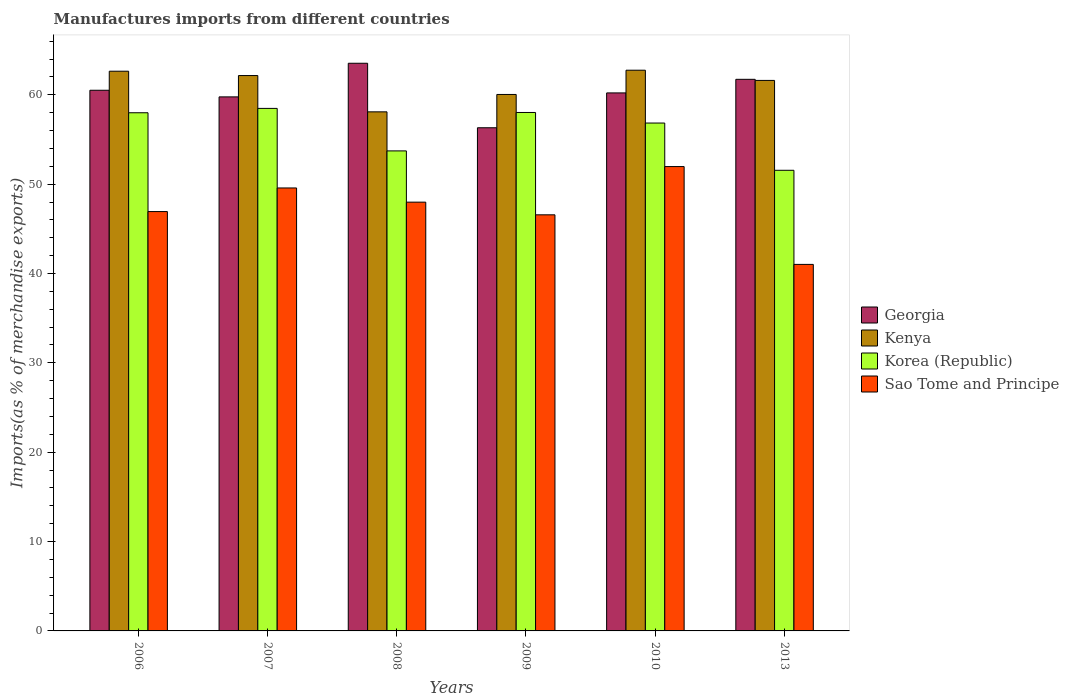How many different coloured bars are there?
Offer a very short reply. 4. Are the number of bars per tick equal to the number of legend labels?
Give a very brief answer. Yes. Are the number of bars on each tick of the X-axis equal?
Keep it short and to the point. Yes. How many bars are there on the 5th tick from the right?
Offer a terse response. 4. In how many cases, is the number of bars for a given year not equal to the number of legend labels?
Keep it short and to the point. 0. What is the percentage of imports to different countries in Sao Tome and Principe in 2008?
Offer a terse response. 47.98. Across all years, what is the maximum percentage of imports to different countries in Sao Tome and Principe?
Keep it short and to the point. 51.97. Across all years, what is the minimum percentage of imports to different countries in Korea (Republic)?
Offer a terse response. 51.55. In which year was the percentage of imports to different countries in Korea (Republic) maximum?
Ensure brevity in your answer.  2007. In which year was the percentage of imports to different countries in Kenya minimum?
Offer a terse response. 2008. What is the total percentage of imports to different countries in Korea (Republic) in the graph?
Your response must be concise. 336.59. What is the difference between the percentage of imports to different countries in Kenya in 2009 and that in 2010?
Your answer should be very brief. -2.72. What is the difference between the percentage of imports to different countries in Sao Tome and Principe in 2007 and the percentage of imports to different countries in Georgia in 2010?
Keep it short and to the point. -10.64. What is the average percentage of imports to different countries in Georgia per year?
Your answer should be compact. 60.34. In the year 2009, what is the difference between the percentage of imports to different countries in Georgia and percentage of imports to different countries in Sao Tome and Principe?
Give a very brief answer. 9.74. In how many years, is the percentage of imports to different countries in Sao Tome and Principe greater than 58 %?
Your response must be concise. 0. What is the ratio of the percentage of imports to different countries in Georgia in 2007 to that in 2008?
Keep it short and to the point. 0.94. What is the difference between the highest and the second highest percentage of imports to different countries in Kenya?
Your answer should be very brief. 0.11. What is the difference between the highest and the lowest percentage of imports to different countries in Sao Tome and Principe?
Ensure brevity in your answer.  10.95. Is the sum of the percentage of imports to different countries in Kenya in 2009 and 2010 greater than the maximum percentage of imports to different countries in Georgia across all years?
Your answer should be very brief. Yes. What does the 2nd bar from the left in 2009 represents?
Offer a very short reply. Kenya. What does the 3rd bar from the right in 2008 represents?
Keep it short and to the point. Kenya. Is it the case that in every year, the sum of the percentage of imports to different countries in Georgia and percentage of imports to different countries in Kenya is greater than the percentage of imports to different countries in Sao Tome and Principe?
Offer a very short reply. Yes. How many years are there in the graph?
Your response must be concise. 6. What is the difference between two consecutive major ticks on the Y-axis?
Offer a very short reply. 10. Are the values on the major ticks of Y-axis written in scientific E-notation?
Your response must be concise. No. Does the graph contain any zero values?
Provide a short and direct response. No. Does the graph contain grids?
Offer a very short reply. No. How many legend labels are there?
Your answer should be very brief. 4. What is the title of the graph?
Offer a terse response. Manufactures imports from different countries. Does "Chile" appear as one of the legend labels in the graph?
Your answer should be compact. No. What is the label or title of the Y-axis?
Your answer should be very brief. Imports(as % of merchandise exports). What is the Imports(as % of merchandise exports) in Georgia in 2006?
Your answer should be very brief. 60.51. What is the Imports(as % of merchandise exports) in Kenya in 2006?
Ensure brevity in your answer.  62.64. What is the Imports(as % of merchandise exports) of Korea (Republic) in 2006?
Your answer should be very brief. 57.99. What is the Imports(as % of merchandise exports) of Sao Tome and Principe in 2006?
Give a very brief answer. 46.93. What is the Imports(as % of merchandise exports) of Georgia in 2007?
Make the answer very short. 59.76. What is the Imports(as % of merchandise exports) in Kenya in 2007?
Your response must be concise. 62.15. What is the Imports(as % of merchandise exports) in Korea (Republic) in 2007?
Offer a very short reply. 58.48. What is the Imports(as % of merchandise exports) in Sao Tome and Principe in 2007?
Provide a succinct answer. 49.57. What is the Imports(as % of merchandise exports) of Georgia in 2008?
Provide a succinct answer. 63.53. What is the Imports(as % of merchandise exports) of Kenya in 2008?
Your answer should be compact. 58.09. What is the Imports(as % of merchandise exports) of Korea (Republic) in 2008?
Provide a succinct answer. 53.72. What is the Imports(as % of merchandise exports) in Sao Tome and Principe in 2008?
Provide a succinct answer. 47.98. What is the Imports(as % of merchandise exports) of Georgia in 2009?
Your answer should be compact. 56.31. What is the Imports(as % of merchandise exports) in Kenya in 2009?
Your answer should be compact. 60.03. What is the Imports(as % of merchandise exports) in Korea (Republic) in 2009?
Ensure brevity in your answer.  58.02. What is the Imports(as % of merchandise exports) of Sao Tome and Principe in 2009?
Your answer should be very brief. 46.57. What is the Imports(as % of merchandise exports) of Georgia in 2010?
Your answer should be compact. 60.21. What is the Imports(as % of merchandise exports) in Kenya in 2010?
Make the answer very short. 62.75. What is the Imports(as % of merchandise exports) in Korea (Republic) in 2010?
Your answer should be very brief. 56.84. What is the Imports(as % of merchandise exports) in Sao Tome and Principe in 2010?
Provide a succinct answer. 51.97. What is the Imports(as % of merchandise exports) in Georgia in 2013?
Offer a very short reply. 61.73. What is the Imports(as % of merchandise exports) of Kenya in 2013?
Provide a succinct answer. 61.61. What is the Imports(as % of merchandise exports) of Korea (Republic) in 2013?
Offer a very short reply. 51.55. What is the Imports(as % of merchandise exports) of Sao Tome and Principe in 2013?
Offer a very short reply. 41.02. Across all years, what is the maximum Imports(as % of merchandise exports) in Georgia?
Give a very brief answer. 63.53. Across all years, what is the maximum Imports(as % of merchandise exports) in Kenya?
Keep it short and to the point. 62.75. Across all years, what is the maximum Imports(as % of merchandise exports) in Korea (Republic)?
Make the answer very short. 58.48. Across all years, what is the maximum Imports(as % of merchandise exports) in Sao Tome and Principe?
Keep it short and to the point. 51.97. Across all years, what is the minimum Imports(as % of merchandise exports) in Georgia?
Your response must be concise. 56.31. Across all years, what is the minimum Imports(as % of merchandise exports) of Kenya?
Your answer should be very brief. 58.09. Across all years, what is the minimum Imports(as % of merchandise exports) of Korea (Republic)?
Your response must be concise. 51.55. Across all years, what is the minimum Imports(as % of merchandise exports) of Sao Tome and Principe?
Offer a very short reply. 41.02. What is the total Imports(as % of merchandise exports) in Georgia in the graph?
Provide a short and direct response. 362.05. What is the total Imports(as % of merchandise exports) in Kenya in the graph?
Provide a short and direct response. 367.27. What is the total Imports(as % of merchandise exports) of Korea (Republic) in the graph?
Your answer should be very brief. 336.59. What is the total Imports(as % of merchandise exports) in Sao Tome and Principe in the graph?
Ensure brevity in your answer.  284.03. What is the difference between the Imports(as % of merchandise exports) in Georgia in 2006 and that in 2007?
Give a very brief answer. 0.74. What is the difference between the Imports(as % of merchandise exports) of Kenya in 2006 and that in 2007?
Your answer should be very brief. 0.49. What is the difference between the Imports(as % of merchandise exports) in Korea (Republic) in 2006 and that in 2007?
Provide a succinct answer. -0.49. What is the difference between the Imports(as % of merchandise exports) of Sao Tome and Principe in 2006 and that in 2007?
Ensure brevity in your answer.  -2.64. What is the difference between the Imports(as % of merchandise exports) in Georgia in 2006 and that in 2008?
Keep it short and to the point. -3.02. What is the difference between the Imports(as % of merchandise exports) of Kenya in 2006 and that in 2008?
Give a very brief answer. 4.55. What is the difference between the Imports(as % of merchandise exports) in Korea (Republic) in 2006 and that in 2008?
Provide a short and direct response. 4.27. What is the difference between the Imports(as % of merchandise exports) of Sao Tome and Principe in 2006 and that in 2008?
Offer a very short reply. -1.05. What is the difference between the Imports(as % of merchandise exports) of Georgia in 2006 and that in 2009?
Offer a terse response. 4.2. What is the difference between the Imports(as % of merchandise exports) of Kenya in 2006 and that in 2009?
Provide a short and direct response. 2.6. What is the difference between the Imports(as % of merchandise exports) of Korea (Republic) in 2006 and that in 2009?
Keep it short and to the point. -0.03. What is the difference between the Imports(as % of merchandise exports) of Sao Tome and Principe in 2006 and that in 2009?
Make the answer very short. 0.36. What is the difference between the Imports(as % of merchandise exports) of Georgia in 2006 and that in 2010?
Make the answer very short. 0.3. What is the difference between the Imports(as % of merchandise exports) of Kenya in 2006 and that in 2010?
Offer a very short reply. -0.11. What is the difference between the Imports(as % of merchandise exports) in Korea (Republic) in 2006 and that in 2010?
Make the answer very short. 1.15. What is the difference between the Imports(as % of merchandise exports) in Sao Tome and Principe in 2006 and that in 2010?
Offer a terse response. -5.04. What is the difference between the Imports(as % of merchandise exports) in Georgia in 2006 and that in 2013?
Offer a terse response. -1.22. What is the difference between the Imports(as % of merchandise exports) in Kenya in 2006 and that in 2013?
Make the answer very short. 1.03. What is the difference between the Imports(as % of merchandise exports) of Korea (Republic) in 2006 and that in 2013?
Your answer should be compact. 6.44. What is the difference between the Imports(as % of merchandise exports) of Sao Tome and Principe in 2006 and that in 2013?
Keep it short and to the point. 5.91. What is the difference between the Imports(as % of merchandise exports) of Georgia in 2007 and that in 2008?
Your answer should be very brief. -3.76. What is the difference between the Imports(as % of merchandise exports) of Kenya in 2007 and that in 2008?
Make the answer very short. 4.06. What is the difference between the Imports(as % of merchandise exports) in Korea (Republic) in 2007 and that in 2008?
Your answer should be compact. 4.76. What is the difference between the Imports(as % of merchandise exports) in Sao Tome and Principe in 2007 and that in 2008?
Offer a very short reply. 1.59. What is the difference between the Imports(as % of merchandise exports) in Georgia in 2007 and that in 2009?
Provide a short and direct response. 3.46. What is the difference between the Imports(as % of merchandise exports) of Kenya in 2007 and that in 2009?
Provide a short and direct response. 2.12. What is the difference between the Imports(as % of merchandise exports) in Korea (Republic) in 2007 and that in 2009?
Provide a short and direct response. 0.46. What is the difference between the Imports(as % of merchandise exports) in Sao Tome and Principe in 2007 and that in 2009?
Offer a very short reply. 3.01. What is the difference between the Imports(as % of merchandise exports) of Georgia in 2007 and that in 2010?
Keep it short and to the point. -0.44. What is the difference between the Imports(as % of merchandise exports) in Kenya in 2007 and that in 2010?
Your response must be concise. -0.6. What is the difference between the Imports(as % of merchandise exports) in Korea (Republic) in 2007 and that in 2010?
Make the answer very short. 1.64. What is the difference between the Imports(as % of merchandise exports) of Sao Tome and Principe in 2007 and that in 2010?
Your response must be concise. -2.39. What is the difference between the Imports(as % of merchandise exports) in Georgia in 2007 and that in 2013?
Your answer should be compact. -1.96. What is the difference between the Imports(as % of merchandise exports) of Kenya in 2007 and that in 2013?
Ensure brevity in your answer.  0.54. What is the difference between the Imports(as % of merchandise exports) of Korea (Republic) in 2007 and that in 2013?
Your response must be concise. 6.93. What is the difference between the Imports(as % of merchandise exports) in Sao Tome and Principe in 2007 and that in 2013?
Provide a short and direct response. 8.56. What is the difference between the Imports(as % of merchandise exports) in Georgia in 2008 and that in 2009?
Offer a terse response. 7.22. What is the difference between the Imports(as % of merchandise exports) of Kenya in 2008 and that in 2009?
Ensure brevity in your answer.  -1.94. What is the difference between the Imports(as % of merchandise exports) in Korea (Republic) in 2008 and that in 2009?
Keep it short and to the point. -4.3. What is the difference between the Imports(as % of merchandise exports) in Sao Tome and Principe in 2008 and that in 2009?
Offer a terse response. 1.42. What is the difference between the Imports(as % of merchandise exports) in Georgia in 2008 and that in 2010?
Your answer should be compact. 3.32. What is the difference between the Imports(as % of merchandise exports) of Kenya in 2008 and that in 2010?
Provide a succinct answer. -4.66. What is the difference between the Imports(as % of merchandise exports) in Korea (Republic) in 2008 and that in 2010?
Your answer should be compact. -3.12. What is the difference between the Imports(as % of merchandise exports) in Sao Tome and Principe in 2008 and that in 2010?
Offer a very short reply. -3.98. What is the difference between the Imports(as % of merchandise exports) in Georgia in 2008 and that in 2013?
Provide a succinct answer. 1.8. What is the difference between the Imports(as % of merchandise exports) in Kenya in 2008 and that in 2013?
Provide a short and direct response. -3.52. What is the difference between the Imports(as % of merchandise exports) of Korea (Republic) in 2008 and that in 2013?
Your answer should be very brief. 2.17. What is the difference between the Imports(as % of merchandise exports) of Sao Tome and Principe in 2008 and that in 2013?
Your answer should be compact. 6.97. What is the difference between the Imports(as % of merchandise exports) of Georgia in 2009 and that in 2010?
Provide a succinct answer. -3.9. What is the difference between the Imports(as % of merchandise exports) in Kenya in 2009 and that in 2010?
Provide a succinct answer. -2.72. What is the difference between the Imports(as % of merchandise exports) of Korea (Republic) in 2009 and that in 2010?
Give a very brief answer. 1.18. What is the difference between the Imports(as % of merchandise exports) of Georgia in 2009 and that in 2013?
Your response must be concise. -5.42. What is the difference between the Imports(as % of merchandise exports) of Kenya in 2009 and that in 2013?
Ensure brevity in your answer.  -1.57. What is the difference between the Imports(as % of merchandise exports) in Korea (Republic) in 2009 and that in 2013?
Provide a short and direct response. 6.47. What is the difference between the Imports(as % of merchandise exports) of Sao Tome and Principe in 2009 and that in 2013?
Provide a short and direct response. 5.55. What is the difference between the Imports(as % of merchandise exports) in Georgia in 2010 and that in 2013?
Your answer should be very brief. -1.52. What is the difference between the Imports(as % of merchandise exports) in Kenya in 2010 and that in 2013?
Give a very brief answer. 1.14. What is the difference between the Imports(as % of merchandise exports) in Korea (Republic) in 2010 and that in 2013?
Provide a short and direct response. 5.29. What is the difference between the Imports(as % of merchandise exports) in Sao Tome and Principe in 2010 and that in 2013?
Offer a very short reply. 10.95. What is the difference between the Imports(as % of merchandise exports) of Georgia in 2006 and the Imports(as % of merchandise exports) of Kenya in 2007?
Make the answer very short. -1.65. What is the difference between the Imports(as % of merchandise exports) of Georgia in 2006 and the Imports(as % of merchandise exports) of Korea (Republic) in 2007?
Provide a short and direct response. 2.03. What is the difference between the Imports(as % of merchandise exports) of Georgia in 2006 and the Imports(as % of merchandise exports) of Sao Tome and Principe in 2007?
Your answer should be compact. 10.93. What is the difference between the Imports(as % of merchandise exports) in Kenya in 2006 and the Imports(as % of merchandise exports) in Korea (Republic) in 2007?
Provide a short and direct response. 4.16. What is the difference between the Imports(as % of merchandise exports) of Kenya in 2006 and the Imports(as % of merchandise exports) of Sao Tome and Principe in 2007?
Your answer should be very brief. 13.06. What is the difference between the Imports(as % of merchandise exports) of Korea (Republic) in 2006 and the Imports(as % of merchandise exports) of Sao Tome and Principe in 2007?
Provide a short and direct response. 8.41. What is the difference between the Imports(as % of merchandise exports) in Georgia in 2006 and the Imports(as % of merchandise exports) in Kenya in 2008?
Give a very brief answer. 2.42. What is the difference between the Imports(as % of merchandise exports) of Georgia in 2006 and the Imports(as % of merchandise exports) of Korea (Republic) in 2008?
Make the answer very short. 6.79. What is the difference between the Imports(as % of merchandise exports) in Georgia in 2006 and the Imports(as % of merchandise exports) in Sao Tome and Principe in 2008?
Provide a short and direct response. 12.52. What is the difference between the Imports(as % of merchandise exports) of Kenya in 2006 and the Imports(as % of merchandise exports) of Korea (Republic) in 2008?
Make the answer very short. 8.92. What is the difference between the Imports(as % of merchandise exports) in Kenya in 2006 and the Imports(as % of merchandise exports) in Sao Tome and Principe in 2008?
Your answer should be compact. 14.65. What is the difference between the Imports(as % of merchandise exports) of Korea (Republic) in 2006 and the Imports(as % of merchandise exports) of Sao Tome and Principe in 2008?
Offer a very short reply. 10. What is the difference between the Imports(as % of merchandise exports) of Georgia in 2006 and the Imports(as % of merchandise exports) of Kenya in 2009?
Provide a short and direct response. 0.47. What is the difference between the Imports(as % of merchandise exports) of Georgia in 2006 and the Imports(as % of merchandise exports) of Korea (Republic) in 2009?
Your response must be concise. 2.49. What is the difference between the Imports(as % of merchandise exports) of Georgia in 2006 and the Imports(as % of merchandise exports) of Sao Tome and Principe in 2009?
Give a very brief answer. 13.94. What is the difference between the Imports(as % of merchandise exports) in Kenya in 2006 and the Imports(as % of merchandise exports) in Korea (Republic) in 2009?
Provide a succinct answer. 4.62. What is the difference between the Imports(as % of merchandise exports) of Kenya in 2006 and the Imports(as % of merchandise exports) of Sao Tome and Principe in 2009?
Offer a terse response. 16.07. What is the difference between the Imports(as % of merchandise exports) of Korea (Republic) in 2006 and the Imports(as % of merchandise exports) of Sao Tome and Principe in 2009?
Your answer should be compact. 11.42. What is the difference between the Imports(as % of merchandise exports) in Georgia in 2006 and the Imports(as % of merchandise exports) in Kenya in 2010?
Offer a very short reply. -2.24. What is the difference between the Imports(as % of merchandise exports) of Georgia in 2006 and the Imports(as % of merchandise exports) of Korea (Republic) in 2010?
Keep it short and to the point. 3.67. What is the difference between the Imports(as % of merchandise exports) of Georgia in 2006 and the Imports(as % of merchandise exports) of Sao Tome and Principe in 2010?
Offer a very short reply. 8.54. What is the difference between the Imports(as % of merchandise exports) in Kenya in 2006 and the Imports(as % of merchandise exports) in Korea (Republic) in 2010?
Offer a very short reply. 5.8. What is the difference between the Imports(as % of merchandise exports) of Kenya in 2006 and the Imports(as % of merchandise exports) of Sao Tome and Principe in 2010?
Your answer should be very brief. 10.67. What is the difference between the Imports(as % of merchandise exports) of Korea (Republic) in 2006 and the Imports(as % of merchandise exports) of Sao Tome and Principe in 2010?
Your answer should be compact. 6.02. What is the difference between the Imports(as % of merchandise exports) of Georgia in 2006 and the Imports(as % of merchandise exports) of Kenya in 2013?
Ensure brevity in your answer.  -1.1. What is the difference between the Imports(as % of merchandise exports) in Georgia in 2006 and the Imports(as % of merchandise exports) in Korea (Republic) in 2013?
Your answer should be compact. 8.96. What is the difference between the Imports(as % of merchandise exports) of Georgia in 2006 and the Imports(as % of merchandise exports) of Sao Tome and Principe in 2013?
Give a very brief answer. 19.49. What is the difference between the Imports(as % of merchandise exports) of Kenya in 2006 and the Imports(as % of merchandise exports) of Korea (Republic) in 2013?
Keep it short and to the point. 11.09. What is the difference between the Imports(as % of merchandise exports) of Kenya in 2006 and the Imports(as % of merchandise exports) of Sao Tome and Principe in 2013?
Provide a short and direct response. 21.62. What is the difference between the Imports(as % of merchandise exports) of Korea (Republic) in 2006 and the Imports(as % of merchandise exports) of Sao Tome and Principe in 2013?
Offer a very short reply. 16.97. What is the difference between the Imports(as % of merchandise exports) of Georgia in 2007 and the Imports(as % of merchandise exports) of Kenya in 2008?
Offer a terse response. 1.67. What is the difference between the Imports(as % of merchandise exports) of Georgia in 2007 and the Imports(as % of merchandise exports) of Korea (Republic) in 2008?
Provide a succinct answer. 6.05. What is the difference between the Imports(as % of merchandise exports) in Georgia in 2007 and the Imports(as % of merchandise exports) in Sao Tome and Principe in 2008?
Offer a terse response. 11.78. What is the difference between the Imports(as % of merchandise exports) in Kenya in 2007 and the Imports(as % of merchandise exports) in Korea (Republic) in 2008?
Provide a succinct answer. 8.43. What is the difference between the Imports(as % of merchandise exports) of Kenya in 2007 and the Imports(as % of merchandise exports) of Sao Tome and Principe in 2008?
Provide a short and direct response. 14.17. What is the difference between the Imports(as % of merchandise exports) of Korea (Republic) in 2007 and the Imports(as % of merchandise exports) of Sao Tome and Principe in 2008?
Ensure brevity in your answer.  10.49. What is the difference between the Imports(as % of merchandise exports) in Georgia in 2007 and the Imports(as % of merchandise exports) in Kenya in 2009?
Your answer should be compact. -0.27. What is the difference between the Imports(as % of merchandise exports) of Georgia in 2007 and the Imports(as % of merchandise exports) of Korea (Republic) in 2009?
Provide a short and direct response. 1.75. What is the difference between the Imports(as % of merchandise exports) in Georgia in 2007 and the Imports(as % of merchandise exports) in Sao Tome and Principe in 2009?
Make the answer very short. 13.2. What is the difference between the Imports(as % of merchandise exports) in Kenya in 2007 and the Imports(as % of merchandise exports) in Korea (Republic) in 2009?
Make the answer very short. 4.13. What is the difference between the Imports(as % of merchandise exports) in Kenya in 2007 and the Imports(as % of merchandise exports) in Sao Tome and Principe in 2009?
Your answer should be very brief. 15.59. What is the difference between the Imports(as % of merchandise exports) in Korea (Republic) in 2007 and the Imports(as % of merchandise exports) in Sao Tome and Principe in 2009?
Keep it short and to the point. 11.91. What is the difference between the Imports(as % of merchandise exports) of Georgia in 2007 and the Imports(as % of merchandise exports) of Kenya in 2010?
Your answer should be compact. -2.99. What is the difference between the Imports(as % of merchandise exports) of Georgia in 2007 and the Imports(as % of merchandise exports) of Korea (Republic) in 2010?
Ensure brevity in your answer.  2.93. What is the difference between the Imports(as % of merchandise exports) in Georgia in 2007 and the Imports(as % of merchandise exports) in Sao Tome and Principe in 2010?
Give a very brief answer. 7.8. What is the difference between the Imports(as % of merchandise exports) in Kenya in 2007 and the Imports(as % of merchandise exports) in Korea (Republic) in 2010?
Give a very brief answer. 5.31. What is the difference between the Imports(as % of merchandise exports) in Kenya in 2007 and the Imports(as % of merchandise exports) in Sao Tome and Principe in 2010?
Offer a very short reply. 10.19. What is the difference between the Imports(as % of merchandise exports) in Korea (Republic) in 2007 and the Imports(as % of merchandise exports) in Sao Tome and Principe in 2010?
Your answer should be compact. 6.51. What is the difference between the Imports(as % of merchandise exports) in Georgia in 2007 and the Imports(as % of merchandise exports) in Kenya in 2013?
Ensure brevity in your answer.  -1.84. What is the difference between the Imports(as % of merchandise exports) in Georgia in 2007 and the Imports(as % of merchandise exports) in Korea (Republic) in 2013?
Provide a short and direct response. 8.21. What is the difference between the Imports(as % of merchandise exports) of Georgia in 2007 and the Imports(as % of merchandise exports) of Sao Tome and Principe in 2013?
Your answer should be very brief. 18.75. What is the difference between the Imports(as % of merchandise exports) of Kenya in 2007 and the Imports(as % of merchandise exports) of Korea (Republic) in 2013?
Your answer should be compact. 10.6. What is the difference between the Imports(as % of merchandise exports) of Kenya in 2007 and the Imports(as % of merchandise exports) of Sao Tome and Principe in 2013?
Provide a short and direct response. 21.13. What is the difference between the Imports(as % of merchandise exports) in Korea (Republic) in 2007 and the Imports(as % of merchandise exports) in Sao Tome and Principe in 2013?
Provide a succinct answer. 17.46. What is the difference between the Imports(as % of merchandise exports) in Georgia in 2008 and the Imports(as % of merchandise exports) in Kenya in 2009?
Offer a terse response. 3.49. What is the difference between the Imports(as % of merchandise exports) of Georgia in 2008 and the Imports(as % of merchandise exports) of Korea (Republic) in 2009?
Your answer should be very brief. 5.51. What is the difference between the Imports(as % of merchandise exports) in Georgia in 2008 and the Imports(as % of merchandise exports) in Sao Tome and Principe in 2009?
Offer a very short reply. 16.96. What is the difference between the Imports(as % of merchandise exports) in Kenya in 2008 and the Imports(as % of merchandise exports) in Korea (Republic) in 2009?
Your response must be concise. 0.07. What is the difference between the Imports(as % of merchandise exports) of Kenya in 2008 and the Imports(as % of merchandise exports) of Sao Tome and Principe in 2009?
Offer a very short reply. 11.52. What is the difference between the Imports(as % of merchandise exports) of Korea (Republic) in 2008 and the Imports(as % of merchandise exports) of Sao Tome and Principe in 2009?
Your response must be concise. 7.15. What is the difference between the Imports(as % of merchandise exports) in Georgia in 2008 and the Imports(as % of merchandise exports) in Kenya in 2010?
Ensure brevity in your answer.  0.78. What is the difference between the Imports(as % of merchandise exports) in Georgia in 2008 and the Imports(as % of merchandise exports) in Korea (Republic) in 2010?
Ensure brevity in your answer.  6.69. What is the difference between the Imports(as % of merchandise exports) of Georgia in 2008 and the Imports(as % of merchandise exports) of Sao Tome and Principe in 2010?
Your answer should be very brief. 11.56. What is the difference between the Imports(as % of merchandise exports) in Kenya in 2008 and the Imports(as % of merchandise exports) in Korea (Republic) in 2010?
Offer a terse response. 1.25. What is the difference between the Imports(as % of merchandise exports) in Kenya in 2008 and the Imports(as % of merchandise exports) in Sao Tome and Principe in 2010?
Ensure brevity in your answer.  6.12. What is the difference between the Imports(as % of merchandise exports) of Korea (Republic) in 2008 and the Imports(as % of merchandise exports) of Sao Tome and Principe in 2010?
Ensure brevity in your answer.  1.75. What is the difference between the Imports(as % of merchandise exports) in Georgia in 2008 and the Imports(as % of merchandise exports) in Kenya in 2013?
Give a very brief answer. 1.92. What is the difference between the Imports(as % of merchandise exports) in Georgia in 2008 and the Imports(as % of merchandise exports) in Korea (Republic) in 2013?
Offer a very short reply. 11.98. What is the difference between the Imports(as % of merchandise exports) of Georgia in 2008 and the Imports(as % of merchandise exports) of Sao Tome and Principe in 2013?
Make the answer very short. 22.51. What is the difference between the Imports(as % of merchandise exports) in Kenya in 2008 and the Imports(as % of merchandise exports) in Korea (Republic) in 2013?
Offer a very short reply. 6.54. What is the difference between the Imports(as % of merchandise exports) in Kenya in 2008 and the Imports(as % of merchandise exports) in Sao Tome and Principe in 2013?
Give a very brief answer. 17.07. What is the difference between the Imports(as % of merchandise exports) of Korea (Republic) in 2008 and the Imports(as % of merchandise exports) of Sao Tome and Principe in 2013?
Ensure brevity in your answer.  12.7. What is the difference between the Imports(as % of merchandise exports) of Georgia in 2009 and the Imports(as % of merchandise exports) of Kenya in 2010?
Provide a short and direct response. -6.44. What is the difference between the Imports(as % of merchandise exports) in Georgia in 2009 and the Imports(as % of merchandise exports) in Korea (Republic) in 2010?
Offer a terse response. -0.53. What is the difference between the Imports(as % of merchandise exports) in Georgia in 2009 and the Imports(as % of merchandise exports) in Sao Tome and Principe in 2010?
Offer a terse response. 4.34. What is the difference between the Imports(as % of merchandise exports) of Kenya in 2009 and the Imports(as % of merchandise exports) of Korea (Republic) in 2010?
Give a very brief answer. 3.2. What is the difference between the Imports(as % of merchandise exports) of Kenya in 2009 and the Imports(as % of merchandise exports) of Sao Tome and Principe in 2010?
Offer a terse response. 8.07. What is the difference between the Imports(as % of merchandise exports) in Korea (Republic) in 2009 and the Imports(as % of merchandise exports) in Sao Tome and Principe in 2010?
Your answer should be very brief. 6.05. What is the difference between the Imports(as % of merchandise exports) in Georgia in 2009 and the Imports(as % of merchandise exports) in Kenya in 2013?
Offer a very short reply. -5.3. What is the difference between the Imports(as % of merchandise exports) of Georgia in 2009 and the Imports(as % of merchandise exports) of Korea (Republic) in 2013?
Offer a very short reply. 4.76. What is the difference between the Imports(as % of merchandise exports) in Georgia in 2009 and the Imports(as % of merchandise exports) in Sao Tome and Principe in 2013?
Offer a very short reply. 15.29. What is the difference between the Imports(as % of merchandise exports) in Kenya in 2009 and the Imports(as % of merchandise exports) in Korea (Republic) in 2013?
Your response must be concise. 8.48. What is the difference between the Imports(as % of merchandise exports) in Kenya in 2009 and the Imports(as % of merchandise exports) in Sao Tome and Principe in 2013?
Make the answer very short. 19.02. What is the difference between the Imports(as % of merchandise exports) in Korea (Republic) in 2009 and the Imports(as % of merchandise exports) in Sao Tome and Principe in 2013?
Your response must be concise. 17. What is the difference between the Imports(as % of merchandise exports) in Georgia in 2010 and the Imports(as % of merchandise exports) in Kenya in 2013?
Provide a succinct answer. -1.4. What is the difference between the Imports(as % of merchandise exports) of Georgia in 2010 and the Imports(as % of merchandise exports) of Korea (Republic) in 2013?
Offer a very short reply. 8.66. What is the difference between the Imports(as % of merchandise exports) of Georgia in 2010 and the Imports(as % of merchandise exports) of Sao Tome and Principe in 2013?
Offer a very short reply. 19.19. What is the difference between the Imports(as % of merchandise exports) in Kenya in 2010 and the Imports(as % of merchandise exports) in Korea (Republic) in 2013?
Provide a succinct answer. 11.2. What is the difference between the Imports(as % of merchandise exports) in Kenya in 2010 and the Imports(as % of merchandise exports) in Sao Tome and Principe in 2013?
Offer a terse response. 21.73. What is the difference between the Imports(as % of merchandise exports) of Korea (Republic) in 2010 and the Imports(as % of merchandise exports) of Sao Tome and Principe in 2013?
Your response must be concise. 15.82. What is the average Imports(as % of merchandise exports) in Georgia per year?
Provide a short and direct response. 60.34. What is the average Imports(as % of merchandise exports) in Kenya per year?
Give a very brief answer. 61.21. What is the average Imports(as % of merchandise exports) in Korea (Republic) per year?
Make the answer very short. 56.1. What is the average Imports(as % of merchandise exports) of Sao Tome and Principe per year?
Your answer should be compact. 47.34. In the year 2006, what is the difference between the Imports(as % of merchandise exports) in Georgia and Imports(as % of merchandise exports) in Kenya?
Your answer should be very brief. -2.13. In the year 2006, what is the difference between the Imports(as % of merchandise exports) in Georgia and Imports(as % of merchandise exports) in Korea (Republic)?
Give a very brief answer. 2.52. In the year 2006, what is the difference between the Imports(as % of merchandise exports) in Georgia and Imports(as % of merchandise exports) in Sao Tome and Principe?
Your answer should be compact. 13.58. In the year 2006, what is the difference between the Imports(as % of merchandise exports) in Kenya and Imports(as % of merchandise exports) in Korea (Republic)?
Your answer should be very brief. 4.65. In the year 2006, what is the difference between the Imports(as % of merchandise exports) in Kenya and Imports(as % of merchandise exports) in Sao Tome and Principe?
Your answer should be compact. 15.71. In the year 2006, what is the difference between the Imports(as % of merchandise exports) in Korea (Republic) and Imports(as % of merchandise exports) in Sao Tome and Principe?
Give a very brief answer. 11.06. In the year 2007, what is the difference between the Imports(as % of merchandise exports) in Georgia and Imports(as % of merchandise exports) in Kenya?
Your answer should be very brief. -2.39. In the year 2007, what is the difference between the Imports(as % of merchandise exports) of Georgia and Imports(as % of merchandise exports) of Korea (Republic)?
Provide a succinct answer. 1.29. In the year 2007, what is the difference between the Imports(as % of merchandise exports) of Georgia and Imports(as % of merchandise exports) of Sao Tome and Principe?
Keep it short and to the point. 10.19. In the year 2007, what is the difference between the Imports(as % of merchandise exports) in Kenya and Imports(as % of merchandise exports) in Korea (Republic)?
Offer a very short reply. 3.68. In the year 2007, what is the difference between the Imports(as % of merchandise exports) of Kenya and Imports(as % of merchandise exports) of Sao Tome and Principe?
Provide a short and direct response. 12.58. In the year 2007, what is the difference between the Imports(as % of merchandise exports) in Korea (Republic) and Imports(as % of merchandise exports) in Sao Tome and Principe?
Your response must be concise. 8.9. In the year 2008, what is the difference between the Imports(as % of merchandise exports) in Georgia and Imports(as % of merchandise exports) in Kenya?
Your answer should be compact. 5.44. In the year 2008, what is the difference between the Imports(as % of merchandise exports) of Georgia and Imports(as % of merchandise exports) of Korea (Republic)?
Ensure brevity in your answer.  9.81. In the year 2008, what is the difference between the Imports(as % of merchandise exports) of Georgia and Imports(as % of merchandise exports) of Sao Tome and Principe?
Provide a succinct answer. 15.54. In the year 2008, what is the difference between the Imports(as % of merchandise exports) in Kenya and Imports(as % of merchandise exports) in Korea (Republic)?
Offer a very short reply. 4.37. In the year 2008, what is the difference between the Imports(as % of merchandise exports) in Kenya and Imports(as % of merchandise exports) in Sao Tome and Principe?
Make the answer very short. 10.11. In the year 2008, what is the difference between the Imports(as % of merchandise exports) of Korea (Republic) and Imports(as % of merchandise exports) of Sao Tome and Principe?
Provide a succinct answer. 5.73. In the year 2009, what is the difference between the Imports(as % of merchandise exports) in Georgia and Imports(as % of merchandise exports) in Kenya?
Provide a succinct answer. -3.73. In the year 2009, what is the difference between the Imports(as % of merchandise exports) of Georgia and Imports(as % of merchandise exports) of Korea (Republic)?
Offer a very short reply. -1.71. In the year 2009, what is the difference between the Imports(as % of merchandise exports) in Georgia and Imports(as % of merchandise exports) in Sao Tome and Principe?
Offer a very short reply. 9.74. In the year 2009, what is the difference between the Imports(as % of merchandise exports) of Kenya and Imports(as % of merchandise exports) of Korea (Republic)?
Your answer should be compact. 2.02. In the year 2009, what is the difference between the Imports(as % of merchandise exports) in Kenya and Imports(as % of merchandise exports) in Sao Tome and Principe?
Give a very brief answer. 13.47. In the year 2009, what is the difference between the Imports(as % of merchandise exports) in Korea (Republic) and Imports(as % of merchandise exports) in Sao Tome and Principe?
Keep it short and to the point. 11.45. In the year 2010, what is the difference between the Imports(as % of merchandise exports) of Georgia and Imports(as % of merchandise exports) of Kenya?
Provide a short and direct response. -2.54. In the year 2010, what is the difference between the Imports(as % of merchandise exports) in Georgia and Imports(as % of merchandise exports) in Korea (Republic)?
Your response must be concise. 3.37. In the year 2010, what is the difference between the Imports(as % of merchandise exports) of Georgia and Imports(as % of merchandise exports) of Sao Tome and Principe?
Your answer should be compact. 8.24. In the year 2010, what is the difference between the Imports(as % of merchandise exports) in Kenya and Imports(as % of merchandise exports) in Korea (Republic)?
Your response must be concise. 5.91. In the year 2010, what is the difference between the Imports(as % of merchandise exports) in Kenya and Imports(as % of merchandise exports) in Sao Tome and Principe?
Your answer should be very brief. 10.78. In the year 2010, what is the difference between the Imports(as % of merchandise exports) in Korea (Republic) and Imports(as % of merchandise exports) in Sao Tome and Principe?
Provide a succinct answer. 4.87. In the year 2013, what is the difference between the Imports(as % of merchandise exports) in Georgia and Imports(as % of merchandise exports) in Kenya?
Give a very brief answer. 0.12. In the year 2013, what is the difference between the Imports(as % of merchandise exports) of Georgia and Imports(as % of merchandise exports) of Korea (Republic)?
Provide a short and direct response. 10.18. In the year 2013, what is the difference between the Imports(as % of merchandise exports) of Georgia and Imports(as % of merchandise exports) of Sao Tome and Principe?
Provide a succinct answer. 20.71. In the year 2013, what is the difference between the Imports(as % of merchandise exports) in Kenya and Imports(as % of merchandise exports) in Korea (Republic)?
Your answer should be very brief. 10.06. In the year 2013, what is the difference between the Imports(as % of merchandise exports) in Kenya and Imports(as % of merchandise exports) in Sao Tome and Principe?
Give a very brief answer. 20.59. In the year 2013, what is the difference between the Imports(as % of merchandise exports) in Korea (Republic) and Imports(as % of merchandise exports) in Sao Tome and Principe?
Your answer should be compact. 10.53. What is the ratio of the Imports(as % of merchandise exports) of Georgia in 2006 to that in 2007?
Your response must be concise. 1.01. What is the ratio of the Imports(as % of merchandise exports) in Kenya in 2006 to that in 2007?
Give a very brief answer. 1.01. What is the ratio of the Imports(as % of merchandise exports) of Sao Tome and Principe in 2006 to that in 2007?
Give a very brief answer. 0.95. What is the ratio of the Imports(as % of merchandise exports) in Georgia in 2006 to that in 2008?
Offer a terse response. 0.95. What is the ratio of the Imports(as % of merchandise exports) of Kenya in 2006 to that in 2008?
Your answer should be compact. 1.08. What is the ratio of the Imports(as % of merchandise exports) of Korea (Republic) in 2006 to that in 2008?
Ensure brevity in your answer.  1.08. What is the ratio of the Imports(as % of merchandise exports) of Sao Tome and Principe in 2006 to that in 2008?
Ensure brevity in your answer.  0.98. What is the ratio of the Imports(as % of merchandise exports) in Georgia in 2006 to that in 2009?
Offer a terse response. 1.07. What is the ratio of the Imports(as % of merchandise exports) in Kenya in 2006 to that in 2009?
Give a very brief answer. 1.04. What is the ratio of the Imports(as % of merchandise exports) of Georgia in 2006 to that in 2010?
Your answer should be very brief. 1. What is the ratio of the Imports(as % of merchandise exports) of Kenya in 2006 to that in 2010?
Offer a terse response. 1. What is the ratio of the Imports(as % of merchandise exports) in Korea (Republic) in 2006 to that in 2010?
Offer a terse response. 1.02. What is the ratio of the Imports(as % of merchandise exports) of Sao Tome and Principe in 2006 to that in 2010?
Ensure brevity in your answer.  0.9. What is the ratio of the Imports(as % of merchandise exports) in Georgia in 2006 to that in 2013?
Offer a terse response. 0.98. What is the ratio of the Imports(as % of merchandise exports) of Kenya in 2006 to that in 2013?
Give a very brief answer. 1.02. What is the ratio of the Imports(as % of merchandise exports) in Korea (Republic) in 2006 to that in 2013?
Your answer should be very brief. 1.12. What is the ratio of the Imports(as % of merchandise exports) of Sao Tome and Principe in 2006 to that in 2013?
Provide a short and direct response. 1.14. What is the ratio of the Imports(as % of merchandise exports) in Georgia in 2007 to that in 2008?
Keep it short and to the point. 0.94. What is the ratio of the Imports(as % of merchandise exports) in Kenya in 2007 to that in 2008?
Ensure brevity in your answer.  1.07. What is the ratio of the Imports(as % of merchandise exports) in Korea (Republic) in 2007 to that in 2008?
Ensure brevity in your answer.  1.09. What is the ratio of the Imports(as % of merchandise exports) in Sao Tome and Principe in 2007 to that in 2008?
Make the answer very short. 1.03. What is the ratio of the Imports(as % of merchandise exports) in Georgia in 2007 to that in 2009?
Provide a succinct answer. 1.06. What is the ratio of the Imports(as % of merchandise exports) of Kenya in 2007 to that in 2009?
Give a very brief answer. 1.04. What is the ratio of the Imports(as % of merchandise exports) of Korea (Republic) in 2007 to that in 2009?
Your answer should be compact. 1.01. What is the ratio of the Imports(as % of merchandise exports) of Sao Tome and Principe in 2007 to that in 2009?
Offer a very short reply. 1.06. What is the ratio of the Imports(as % of merchandise exports) of Kenya in 2007 to that in 2010?
Offer a terse response. 0.99. What is the ratio of the Imports(as % of merchandise exports) of Korea (Republic) in 2007 to that in 2010?
Offer a very short reply. 1.03. What is the ratio of the Imports(as % of merchandise exports) of Sao Tome and Principe in 2007 to that in 2010?
Your answer should be compact. 0.95. What is the ratio of the Imports(as % of merchandise exports) of Georgia in 2007 to that in 2013?
Your response must be concise. 0.97. What is the ratio of the Imports(as % of merchandise exports) in Kenya in 2007 to that in 2013?
Keep it short and to the point. 1.01. What is the ratio of the Imports(as % of merchandise exports) in Korea (Republic) in 2007 to that in 2013?
Offer a very short reply. 1.13. What is the ratio of the Imports(as % of merchandise exports) in Sao Tome and Principe in 2007 to that in 2013?
Your response must be concise. 1.21. What is the ratio of the Imports(as % of merchandise exports) of Georgia in 2008 to that in 2009?
Offer a terse response. 1.13. What is the ratio of the Imports(as % of merchandise exports) in Kenya in 2008 to that in 2009?
Provide a short and direct response. 0.97. What is the ratio of the Imports(as % of merchandise exports) in Korea (Republic) in 2008 to that in 2009?
Your answer should be very brief. 0.93. What is the ratio of the Imports(as % of merchandise exports) in Sao Tome and Principe in 2008 to that in 2009?
Offer a very short reply. 1.03. What is the ratio of the Imports(as % of merchandise exports) in Georgia in 2008 to that in 2010?
Give a very brief answer. 1.06. What is the ratio of the Imports(as % of merchandise exports) of Kenya in 2008 to that in 2010?
Make the answer very short. 0.93. What is the ratio of the Imports(as % of merchandise exports) of Korea (Republic) in 2008 to that in 2010?
Make the answer very short. 0.95. What is the ratio of the Imports(as % of merchandise exports) in Sao Tome and Principe in 2008 to that in 2010?
Ensure brevity in your answer.  0.92. What is the ratio of the Imports(as % of merchandise exports) in Georgia in 2008 to that in 2013?
Offer a very short reply. 1.03. What is the ratio of the Imports(as % of merchandise exports) of Kenya in 2008 to that in 2013?
Your answer should be compact. 0.94. What is the ratio of the Imports(as % of merchandise exports) of Korea (Republic) in 2008 to that in 2013?
Provide a short and direct response. 1.04. What is the ratio of the Imports(as % of merchandise exports) in Sao Tome and Principe in 2008 to that in 2013?
Make the answer very short. 1.17. What is the ratio of the Imports(as % of merchandise exports) of Georgia in 2009 to that in 2010?
Provide a succinct answer. 0.94. What is the ratio of the Imports(as % of merchandise exports) of Kenya in 2009 to that in 2010?
Your answer should be compact. 0.96. What is the ratio of the Imports(as % of merchandise exports) in Korea (Republic) in 2009 to that in 2010?
Provide a short and direct response. 1.02. What is the ratio of the Imports(as % of merchandise exports) in Sao Tome and Principe in 2009 to that in 2010?
Your answer should be very brief. 0.9. What is the ratio of the Imports(as % of merchandise exports) in Georgia in 2009 to that in 2013?
Offer a terse response. 0.91. What is the ratio of the Imports(as % of merchandise exports) in Kenya in 2009 to that in 2013?
Offer a very short reply. 0.97. What is the ratio of the Imports(as % of merchandise exports) in Korea (Republic) in 2009 to that in 2013?
Your answer should be very brief. 1.13. What is the ratio of the Imports(as % of merchandise exports) of Sao Tome and Principe in 2009 to that in 2013?
Provide a succinct answer. 1.14. What is the ratio of the Imports(as % of merchandise exports) in Georgia in 2010 to that in 2013?
Offer a terse response. 0.98. What is the ratio of the Imports(as % of merchandise exports) of Kenya in 2010 to that in 2013?
Offer a terse response. 1.02. What is the ratio of the Imports(as % of merchandise exports) of Korea (Republic) in 2010 to that in 2013?
Give a very brief answer. 1.1. What is the ratio of the Imports(as % of merchandise exports) in Sao Tome and Principe in 2010 to that in 2013?
Provide a succinct answer. 1.27. What is the difference between the highest and the second highest Imports(as % of merchandise exports) in Georgia?
Provide a short and direct response. 1.8. What is the difference between the highest and the second highest Imports(as % of merchandise exports) of Kenya?
Ensure brevity in your answer.  0.11. What is the difference between the highest and the second highest Imports(as % of merchandise exports) of Korea (Republic)?
Provide a succinct answer. 0.46. What is the difference between the highest and the second highest Imports(as % of merchandise exports) in Sao Tome and Principe?
Provide a short and direct response. 2.39. What is the difference between the highest and the lowest Imports(as % of merchandise exports) in Georgia?
Provide a succinct answer. 7.22. What is the difference between the highest and the lowest Imports(as % of merchandise exports) in Kenya?
Make the answer very short. 4.66. What is the difference between the highest and the lowest Imports(as % of merchandise exports) of Korea (Republic)?
Your answer should be very brief. 6.93. What is the difference between the highest and the lowest Imports(as % of merchandise exports) of Sao Tome and Principe?
Provide a succinct answer. 10.95. 